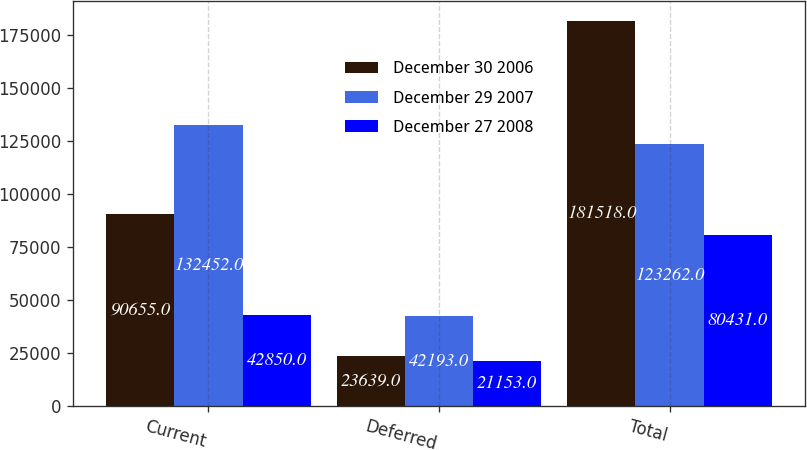Convert chart. <chart><loc_0><loc_0><loc_500><loc_500><stacked_bar_chart><ecel><fcel>Current<fcel>Deferred<fcel>Total<nl><fcel>December 30 2006<fcel>90655<fcel>23639<fcel>181518<nl><fcel>December 29 2007<fcel>132452<fcel>42193<fcel>123262<nl><fcel>December 27 2008<fcel>42850<fcel>21153<fcel>80431<nl></chart> 